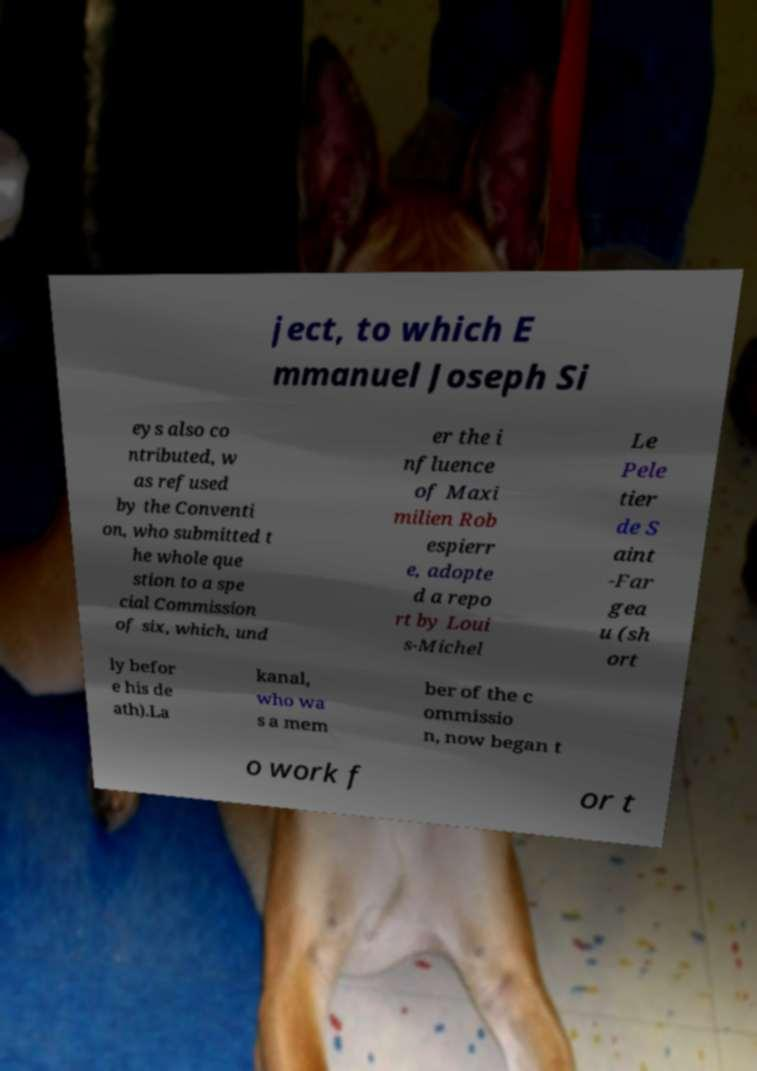What messages or text are displayed in this image? I need them in a readable, typed format. ject, to which E mmanuel Joseph Si eys also co ntributed, w as refused by the Conventi on, who submitted t he whole que stion to a spe cial Commission of six, which, und er the i nfluence of Maxi milien Rob espierr e, adopte d a repo rt by Loui s-Michel Le Pele tier de S aint -Far gea u (sh ort ly befor e his de ath).La kanal, who wa s a mem ber of the c ommissio n, now began t o work f or t 